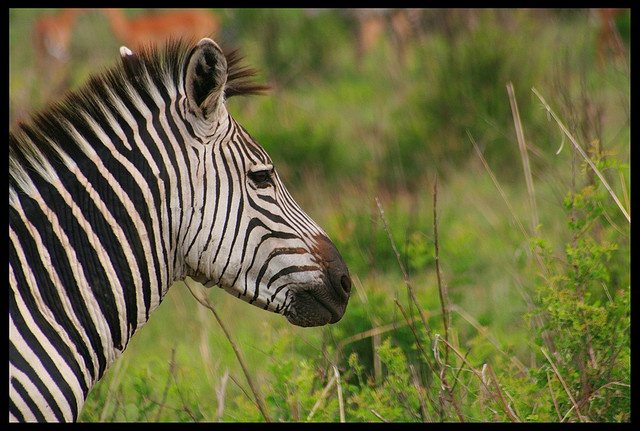Describe the objects in this image and their specific colors. I can see a zebra in black, darkgray, and tan tones in this image. 